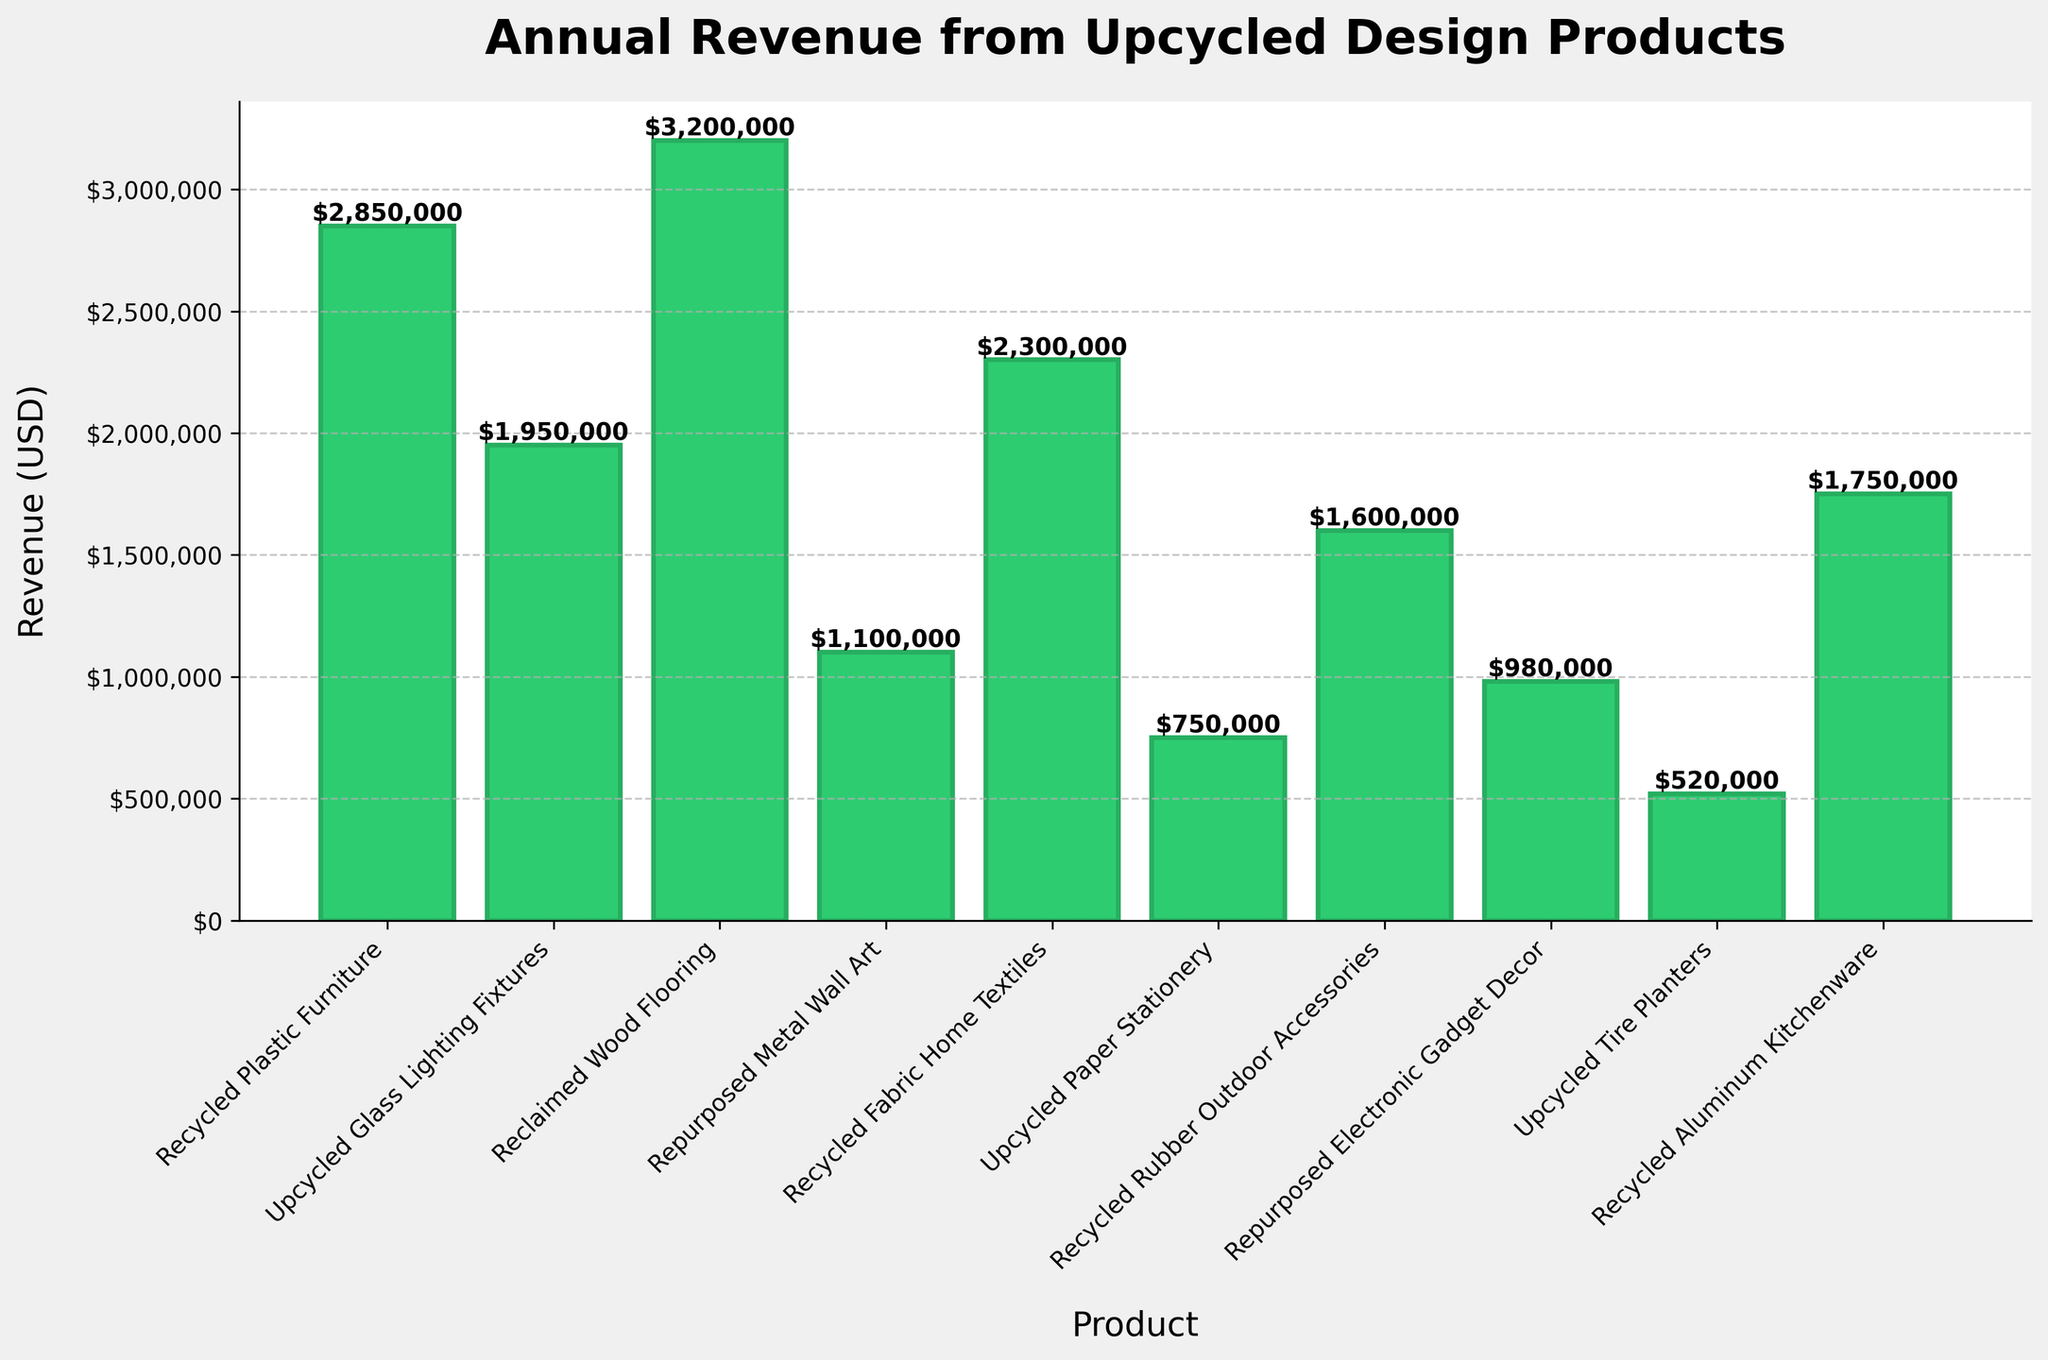What is the highest revenue generated by any product? To find the highest revenue, look at each bar's value. The tallest bar signifies the highest revenue. Here, Reclaimed Wood Flooring has the highest revenue.
Answer: $3,200,000 Which product generates the least revenue? To determine the product with the least revenue, look for the shortest bar. The Upcycled Tire Planters bar is the shortest, indicating the least revenue.
Answer: $520,000 What is the total revenue generated by Recycled Plastic Furniture, Recycled Fabric Home Textiles, and Recycled Aluminum Kitchenware combined? Add the revenues of Recycled Plastic Furniture ($2,850,000), Recycled Fabric Home Textiles ($2,300,000), and Recycled Aluminum Kitchenware ($1,750,000): $2,850,000 + $2,300,000 + $1,750,000 = $6,900,000.
Answer: $6,900,000 Which product generates more revenue: Recycled Rubber Outdoor Accessories or Repurposed Electronic Gadget Decor? Compare the heights of the bars for Recycled Rubber Outdoor Accessories and Repurposed Electronic Gadget Decor. Recycled Rubber Outdoor Accessories' bar is taller.
Answer: Recycled Rubber Outdoor Accessories What is the approximate difference in revenue between the highest and the lowest revenue-generating products? Subtract the revenue of the lowest revenue-generating product (Upcycled Tire Planters, $520,000) from the highest (Reclaimed Wood Flooring, $3,200,000): $3,200,000 - $520,000 = $2,680,000.
Answer: $2,680,000 Which two products have the closest revenues, and what is their difference? Closest revenue will result from comparing the heights of the bars that appear similar. Recycled Plastic Furniture ($2,850,000) and Recycled Fabric Home Textiles ($2,300,000) are close. Difference: $2,850,000 - $2,300,000 = $550,000.
Answer: Recycled Plastic Furniture and Recycled Fabric Home Textiles, $550,000 What is the median revenue of all the products? List all revenues in ascending order: $520,000, $750,000, $980,000, $1,100,000, $1,600,000, $1,750,000, $1,950,000, $2,300,000, $2,850,000, $3,200,000. The median is the average of the 5th and 6th values: ($1,600,000 + $1,750,000) / 2 = $1,675,000.
Answer: $1,675,000 